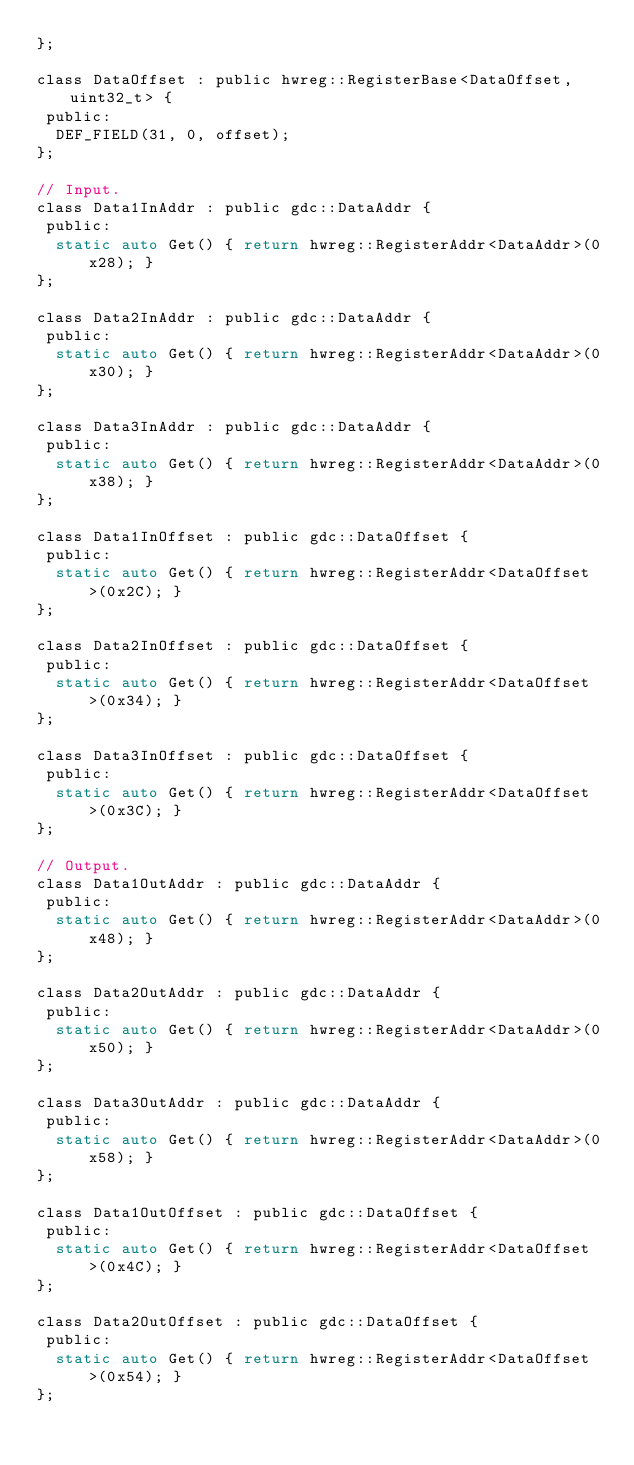Convert code to text. <code><loc_0><loc_0><loc_500><loc_500><_C_>};

class DataOffset : public hwreg::RegisterBase<DataOffset, uint32_t> {
 public:
  DEF_FIELD(31, 0, offset);
};

// Input.
class Data1InAddr : public gdc::DataAddr {
 public:
  static auto Get() { return hwreg::RegisterAddr<DataAddr>(0x28); }
};

class Data2InAddr : public gdc::DataAddr {
 public:
  static auto Get() { return hwreg::RegisterAddr<DataAddr>(0x30); }
};

class Data3InAddr : public gdc::DataAddr {
 public:
  static auto Get() { return hwreg::RegisterAddr<DataAddr>(0x38); }
};

class Data1InOffset : public gdc::DataOffset {
 public:
  static auto Get() { return hwreg::RegisterAddr<DataOffset>(0x2C); }
};

class Data2InOffset : public gdc::DataOffset {
 public:
  static auto Get() { return hwreg::RegisterAddr<DataOffset>(0x34); }
};

class Data3InOffset : public gdc::DataOffset {
 public:
  static auto Get() { return hwreg::RegisterAddr<DataOffset>(0x3C); }
};

// Output.
class Data1OutAddr : public gdc::DataAddr {
 public:
  static auto Get() { return hwreg::RegisterAddr<DataAddr>(0x48); }
};

class Data2OutAddr : public gdc::DataAddr {
 public:
  static auto Get() { return hwreg::RegisterAddr<DataAddr>(0x50); }
};

class Data3OutAddr : public gdc::DataAddr {
 public:
  static auto Get() { return hwreg::RegisterAddr<DataAddr>(0x58); }
};

class Data1OutOffset : public gdc::DataOffset {
 public:
  static auto Get() { return hwreg::RegisterAddr<DataOffset>(0x4C); }
};

class Data2OutOffset : public gdc::DataOffset {
 public:
  static auto Get() { return hwreg::RegisterAddr<DataOffset>(0x54); }
};
</code> 